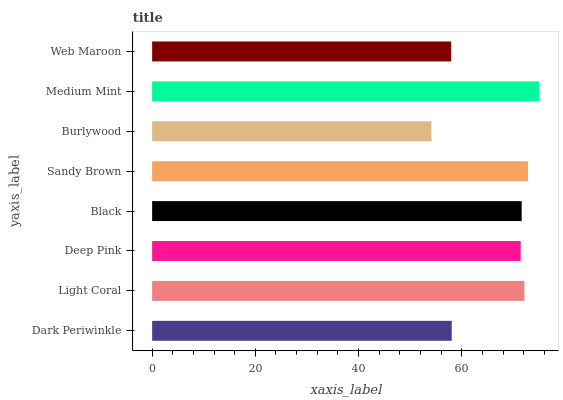Is Burlywood the minimum?
Answer yes or no. Yes. Is Medium Mint the maximum?
Answer yes or no. Yes. Is Light Coral the minimum?
Answer yes or no. No. Is Light Coral the maximum?
Answer yes or no. No. Is Light Coral greater than Dark Periwinkle?
Answer yes or no. Yes. Is Dark Periwinkle less than Light Coral?
Answer yes or no. Yes. Is Dark Periwinkle greater than Light Coral?
Answer yes or no. No. Is Light Coral less than Dark Periwinkle?
Answer yes or no. No. Is Black the high median?
Answer yes or no. Yes. Is Deep Pink the low median?
Answer yes or no. Yes. Is Medium Mint the high median?
Answer yes or no. No. Is Burlywood the low median?
Answer yes or no. No. 